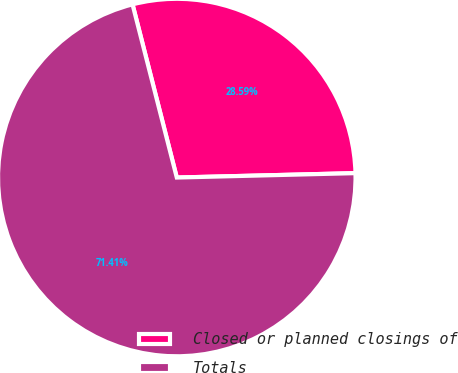Convert chart. <chart><loc_0><loc_0><loc_500><loc_500><pie_chart><fcel>Closed or planned closings of<fcel>Totals<nl><fcel>28.59%<fcel>71.41%<nl></chart> 